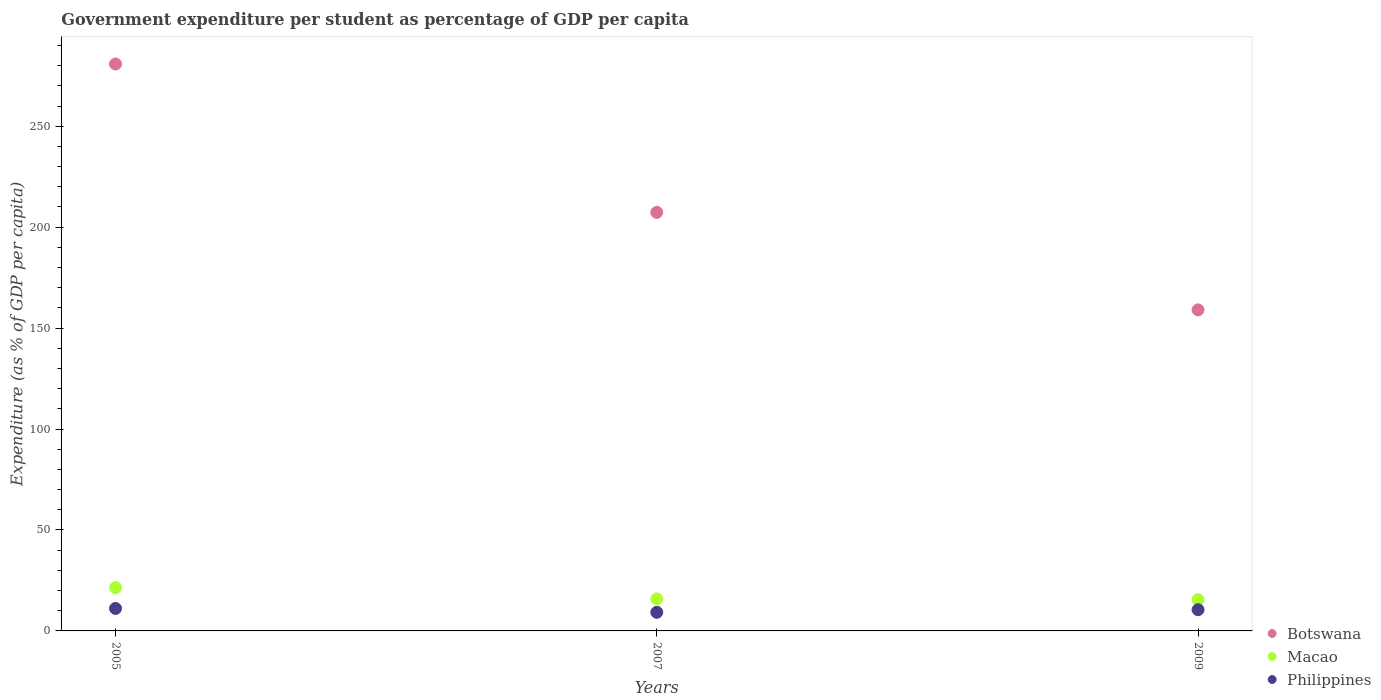What is the percentage of expenditure per student in Botswana in 2007?
Ensure brevity in your answer.  207.31. Across all years, what is the maximum percentage of expenditure per student in Botswana?
Offer a very short reply. 280.81. Across all years, what is the minimum percentage of expenditure per student in Botswana?
Provide a succinct answer. 159.02. In which year was the percentage of expenditure per student in Botswana maximum?
Provide a short and direct response. 2005. What is the total percentage of expenditure per student in Macao in the graph?
Give a very brief answer. 52.77. What is the difference between the percentage of expenditure per student in Botswana in 2005 and that in 2007?
Your answer should be compact. 73.5. What is the difference between the percentage of expenditure per student in Macao in 2009 and the percentage of expenditure per student in Botswana in 2007?
Your answer should be very brief. -191.85. What is the average percentage of expenditure per student in Philippines per year?
Your response must be concise. 10.29. In the year 2005, what is the difference between the percentage of expenditure per student in Macao and percentage of expenditure per student in Botswana?
Offer a very short reply. -259.4. In how many years, is the percentage of expenditure per student in Macao greater than 30 %?
Offer a terse response. 0. What is the ratio of the percentage of expenditure per student in Philippines in 2005 to that in 2009?
Offer a terse response. 1.06. What is the difference between the highest and the second highest percentage of expenditure per student in Botswana?
Your answer should be very brief. 73.5. What is the difference between the highest and the lowest percentage of expenditure per student in Botswana?
Your answer should be very brief. 121.79. In how many years, is the percentage of expenditure per student in Macao greater than the average percentage of expenditure per student in Macao taken over all years?
Offer a terse response. 1. Is it the case that in every year, the sum of the percentage of expenditure per student in Macao and percentage of expenditure per student in Philippines  is greater than the percentage of expenditure per student in Botswana?
Provide a short and direct response. No. Is the percentage of expenditure per student in Macao strictly greater than the percentage of expenditure per student in Botswana over the years?
Provide a short and direct response. No. Is the percentage of expenditure per student in Macao strictly less than the percentage of expenditure per student in Botswana over the years?
Your answer should be compact. Yes. How many dotlines are there?
Your answer should be very brief. 3. What is the difference between two consecutive major ticks on the Y-axis?
Your response must be concise. 50. Are the values on the major ticks of Y-axis written in scientific E-notation?
Your answer should be very brief. No. What is the title of the graph?
Offer a very short reply. Government expenditure per student as percentage of GDP per capita. What is the label or title of the Y-axis?
Ensure brevity in your answer.  Expenditure (as % of GDP per capita). What is the Expenditure (as % of GDP per capita) in Botswana in 2005?
Offer a terse response. 280.81. What is the Expenditure (as % of GDP per capita) in Macao in 2005?
Provide a succinct answer. 21.41. What is the Expenditure (as % of GDP per capita) in Philippines in 2005?
Offer a terse response. 11.13. What is the Expenditure (as % of GDP per capita) in Botswana in 2007?
Provide a short and direct response. 207.31. What is the Expenditure (as % of GDP per capita) in Macao in 2007?
Your response must be concise. 15.89. What is the Expenditure (as % of GDP per capita) in Philippines in 2007?
Provide a succinct answer. 9.23. What is the Expenditure (as % of GDP per capita) of Botswana in 2009?
Provide a short and direct response. 159.02. What is the Expenditure (as % of GDP per capita) of Macao in 2009?
Your answer should be compact. 15.46. What is the Expenditure (as % of GDP per capita) of Philippines in 2009?
Your response must be concise. 10.51. Across all years, what is the maximum Expenditure (as % of GDP per capita) in Botswana?
Provide a succinct answer. 280.81. Across all years, what is the maximum Expenditure (as % of GDP per capita) of Macao?
Keep it short and to the point. 21.41. Across all years, what is the maximum Expenditure (as % of GDP per capita) of Philippines?
Your answer should be very brief. 11.13. Across all years, what is the minimum Expenditure (as % of GDP per capita) in Botswana?
Offer a terse response. 159.02. Across all years, what is the minimum Expenditure (as % of GDP per capita) in Macao?
Ensure brevity in your answer.  15.46. Across all years, what is the minimum Expenditure (as % of GDP per capita) of Philippines?
Your answer should be compact. 9.23. What is the total Expenditure (as % of GDP per capita) in Botswana in the graph?
Offer a very short reply. 647.14. What is the total Expenditure (as % of GDP per capita) of Macao in the graph?
Your answer should be compact. 52.77. What is the total Expenditure (as % of GDP per capita) of Philippines in the graph?
Offer a terse response. 30.87. What is the difference between the Expenditure (as % of GDP per capita) in Botswana in 2005 and that in 2007?
Your answer should be very brief. 73.5. What is the difference between the Expenditure (as % of GDP per capita) in Macao in 2005 and that in 2007?
Give a very brief answer. 5.52. What is the difference between the Expenditure (as % of GDP per capita) of Philippines in 2005 and that in 2007?
Your answer should be compact. 1.9. What is the difference between the Expenditure (as % of GDP per capita) in Botswana in 2005 and that in 2009?
Ensure brevity in your answer.  121.79. What is the difference between the Expenditure (as % of GDP per capita) in Macao in 2005 and that in 2009?
Your answer should be very brief. 5.95. What is the difference between the Expenditure (as % of GDP per capita) of Philippines in 2005 and that in 2009?
Your response must be concise. 0.63. What is the difference between the Expenditure (as % of GDP per capita) of Botswana in 2007 and that in 2009?
Your answer should be very brief. 48.29. What is the difference between the Expenditure (as % of GDP per capita) of Macao in 2007 and that in 2009?
Make the answer very short. 0.43. What is the difference between the Expenditure (as % of GDP per capita) in Philippines in 2007 and that in 2009?
Offer a terse response. -1.28. What is the difference between the Expenditure (as % of GDP per capita) of Botswana in 2005 and the Expenditure (as % of GDP per capita) of Macao in 2007?
Offer a terse response. 264.91. What is the difference between the Expenditure (as % of GDP per capita) of Botswana in 2005 and the Expenditure (as % of GDP per capita) of Philippines in 2007?
Provide a short and direct response. 271.58. What is the difference between the Expenditure (as % of GDP per capita) of Macao in 2005 and the Expenditure (as % of GDP per capita) of Philippines in 2007?
Your answer should be very brief. 12.19. What is the difference between the Expenditure (as % of GDP per capita) in Botswana in 2005 and the Expenditure (as % of GDP per capita) in Macao in 2009?
Offer a terse response. 265.34. What is the difference between the Expenditure (as % of GDP per capita) in Botswana in 2005 and the Expenditure (as % of GDP per capita) in Philippines in 2009?
Offer a very short reply. 270.3. What is the difference between the Expenditure (as % of GDP per capita) in Macao in 2005 and the Expenditure (as % of GDP per capita) in Philippines in 2009?
Ensure brevity in your answer.  10.91. What is the difference between the Expenditure (as % of GDP per capita) of Botswana in 2007 and the Expenditure (as % of GDP per capita) of Macao in 2009?
Offer a very short reply. 191.85. What is the difference between the Expenditure (as % of GDP per capita) of Botswana in 2007 and the Expenditure (as % of GDP per capita) of Philippines in 2009?
Ensure brevity in your answer.  196.8. What is the difference between the Expenditure (as % of GDP per capita) in Macao in 2007 and the Expenditure (as % of GDP per capita) in Philippines in 2009?
Offer a very short reply. 5.39. What is the average Expenditure (as % of GDP per capita) in Botswana per year?
Make the answer very short. 215.71. What is the average Expenditure (as % of GDP per capita) in Macao per year?
Your answer should be very brief. 17.59. What is the average Expenditure (as % of GDP per capita) in Philippines per year?
Provide a short and direct response. 10.29. In the year 2005, what is the difference between the Expenditure (as % of GDP per capita) of Botswana and Expenditure (as % of GDP per capita) of Macao?
Your answer should be compact. 259.4. In the year 2005, what is the difference between the Expenditure (as % of GDP per capita) of Botswana and Expenditure (as % of GDP per capita) of Philippines?
Your answer should be compact. 269.68. In the year 2005, what is the difference between the Expenditure (as % of GDP per capita) in Macao and Expenditure (as % of GDP per capita) in Philippines?
Ensure brevity in your answer.  10.28. In the year 2007, what is the difference between the Expenditure (as % of GDP per capita) of Botswana and Expenditure (as % of GDP per capita) of Macao?
Keep it short and to the point. 191.42. In the year 2007, what is the difference between the Expenditure (as % of GDP per capita) in Botswana and Expenditure (as % of GDP per capita) in Philippines?
Provide a succinct answer. 198.08. In the year 2007, what is the difference between the Expenditure (as % of GDP per capita) of Macao and Expenditure (as % of GDP per capita) of Philippines?
Your response must be concise. 6.67. In the year 2009, what is the difference between the Expenditure (as % of GDP per capita) of Botswana and Expenditure (as % of GDP per capita) of Macao?
Your answer should be very brief. 143.55. In the year 2009, what is the difference between the Expenditure (as % of GDP per capita) of Botswana and Expenditure (as % of GDP per capita) of Philippines?
Give a very brief answer. 148.51. In the year 2009, what is the difference between the Expenditure (as % of GDP per capita) of Macao and Expenditure (as % of GDP per capita) of Philippines?
Keep it short and to the point. 4.96. What is the ratio of the Expenditure (as % of GDP per capita) in Botswana in 2005 to that in 2007?
Ensure brevity in your answer.  1.35. What is the ratio of the Expenditure (as % of GDP per capita) in Macao in 2005 to that in 2007?
Your response must be concise. 1.35. What is the ratio of the Expenditure (as % of GDP per capita) in Philippines in 2005 to that in 2007?
Keep it short and to the point. 1.21. What is the ratio of the Expenditure (as % of GDP per capita) in Botswana in 2005 to that in 2009?
Offer a very short reply. 1.77. What is the ratio of the Expenditure (as % of GDP per capita) in Macao in 2005 to that in 2009?
Your answer should be compact. 1.38. What is the ratio of the Expenditure (as % of GDP per capita) of Philippines in 2005 to that in 2009?
Your response must be concise. 1.06. What is the ratio of the Expenditure (as % of GDP per capita) of Botswana in 2007 to that in 2009?
Offer a terse response. 1.3. What is the ratio of the Expenditure (as % of GDP per capita) in Macao in 2007 to that in 2009?
Make the answer very short. 1.03. What is the ratio of the Expenditure (as % of GDP per capita) of Philippines in 2007 to that in 2009?
Your answer should be compact. 0.88. What is the difference between the highest and the second highest Expenditure (as % of GDP per capita) of Botswana?
Offer a very short reply. 73.5. What is the difference between the highest and the second highest Expenditure (as % of GDP per capita) in Macao?
Give a very brief answer. 5.52. What is the difference between the highest and the second highest Expenditure (as % of GDP per capita) of Philippines?
Offer a terse response. 0.63. What is the difference between the highest and the lowest Expenditure (as % of GDP per capita) in Botswana?
Offer a terse response. 121.79. What is the difference between the highest and the lowest Expenditure (as % of GDP per capita) of Macao?
Your response must be concise. 5.95. What is the difference between the highest and the lowest Expenditure (as % of GDP per capita) of Philippines?
Your answer should be compact. 1.9. 